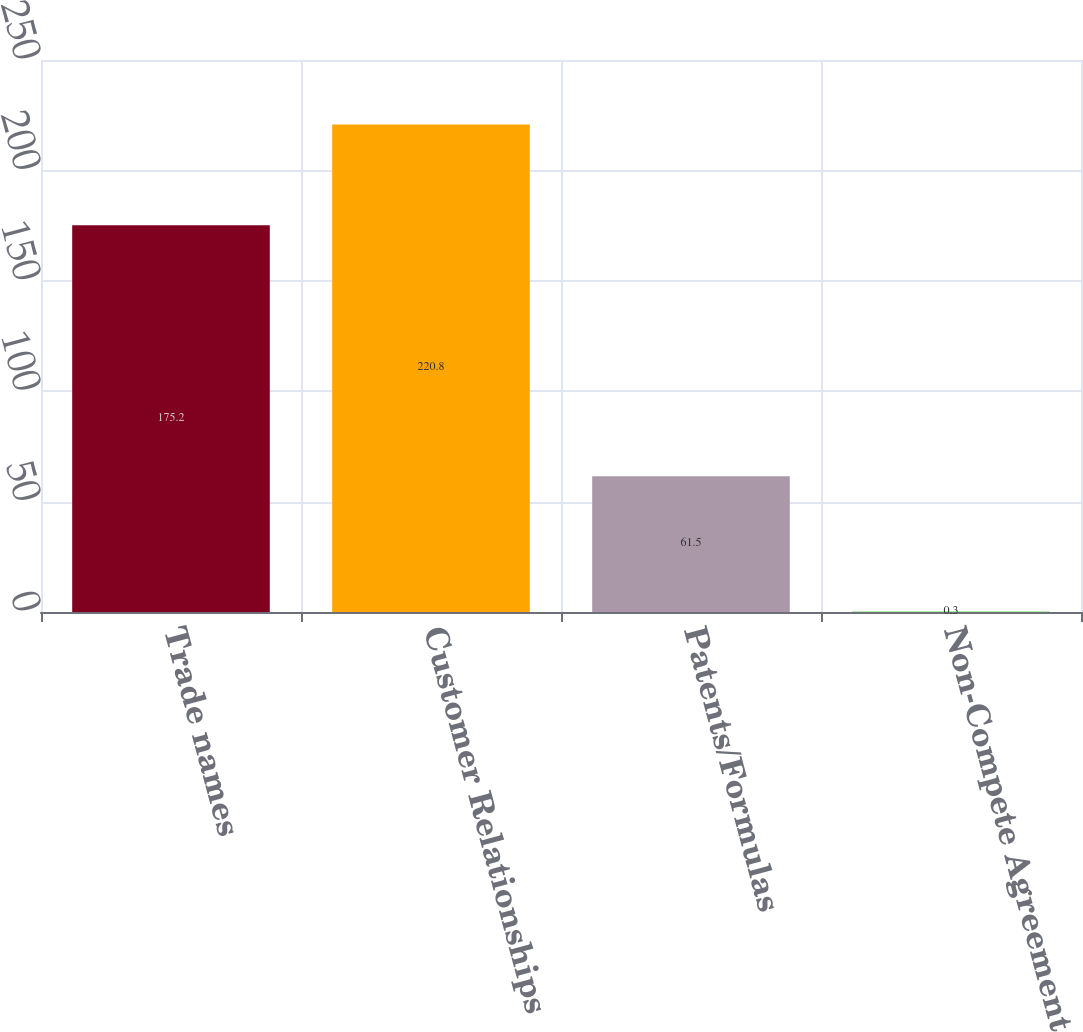<chart> <loc_0><loc_0><loc_500><loc_500><bar_chart><fcel>Trade names<fcel>Customer Relationships<fcel>Patents/Formulas<fcel>Non-Compete Agreement<nl><fcel>175.2<fcel>220.8<fcel>61.5<fcel>0.3<nl></chart> 